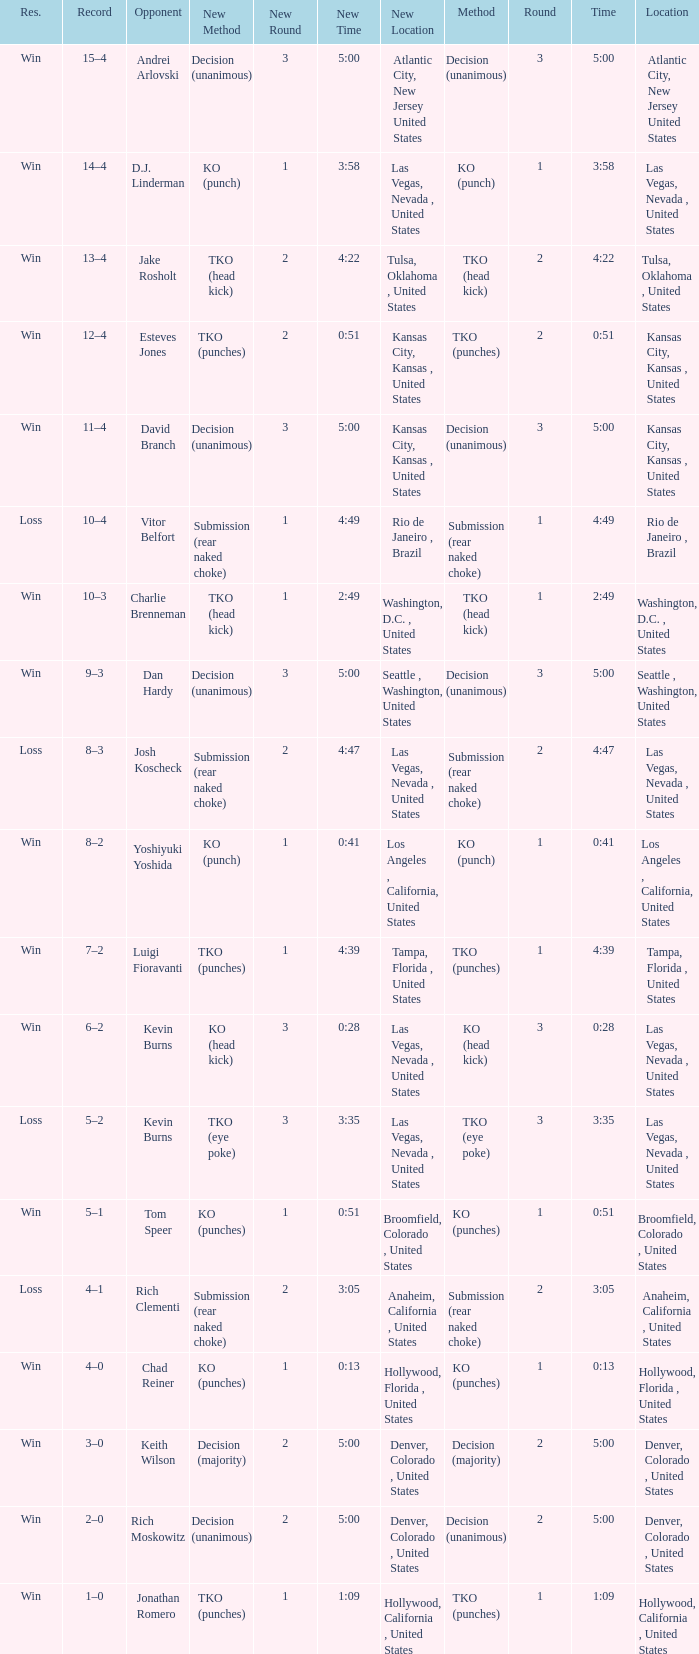What is the highest round number with a time of 4:39? 1.0. 